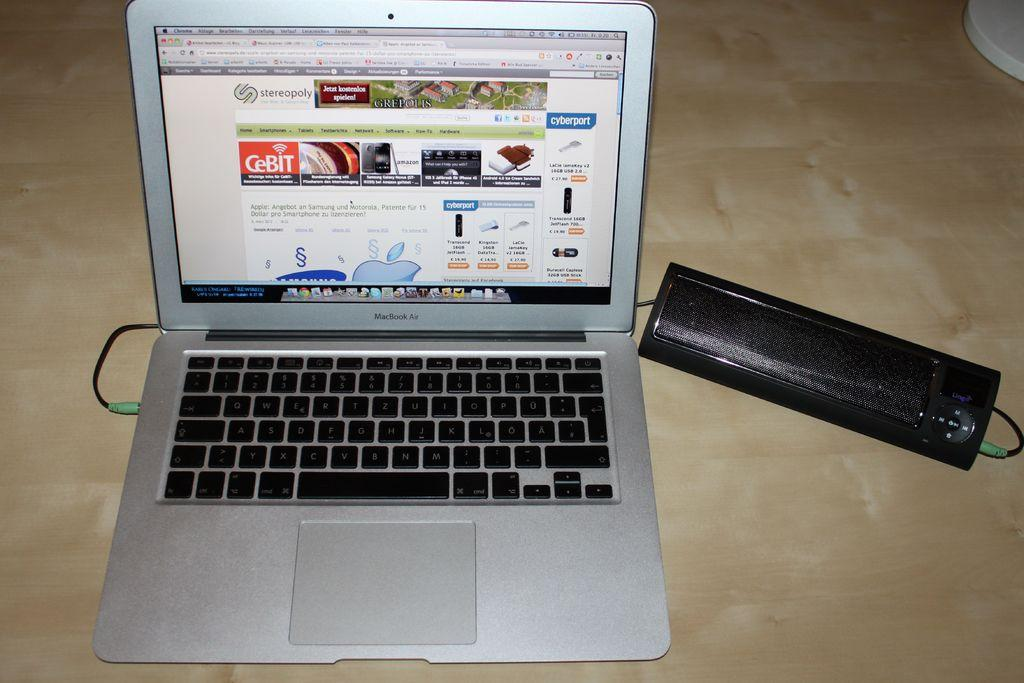Provide a one-sentence caption for the provided image. A laptop is open and a web page is showing which contains German text concerning mobile phones. 